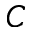<formula> <loc_0><loc_0><loc_500><loc_500>C</formula> 